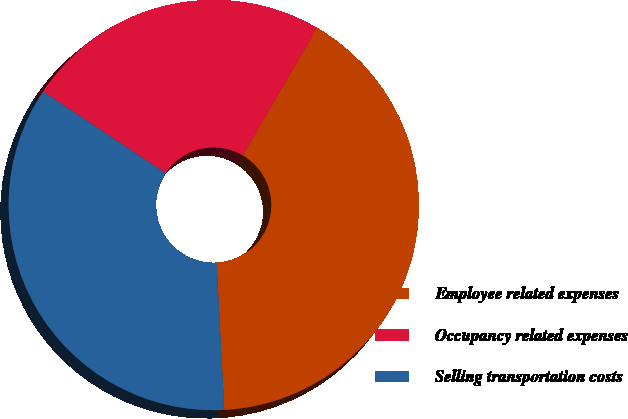<chart> <loc_0><loc_0><loc_500><loc_500><pie_chart><fcel>Employee related expenses<fcel>Occupancy related expenses<fcel>Selling transportation costs<nl><fcel>40.77%<fcel>24.04%<fcel>35.19%<nl></chart> 